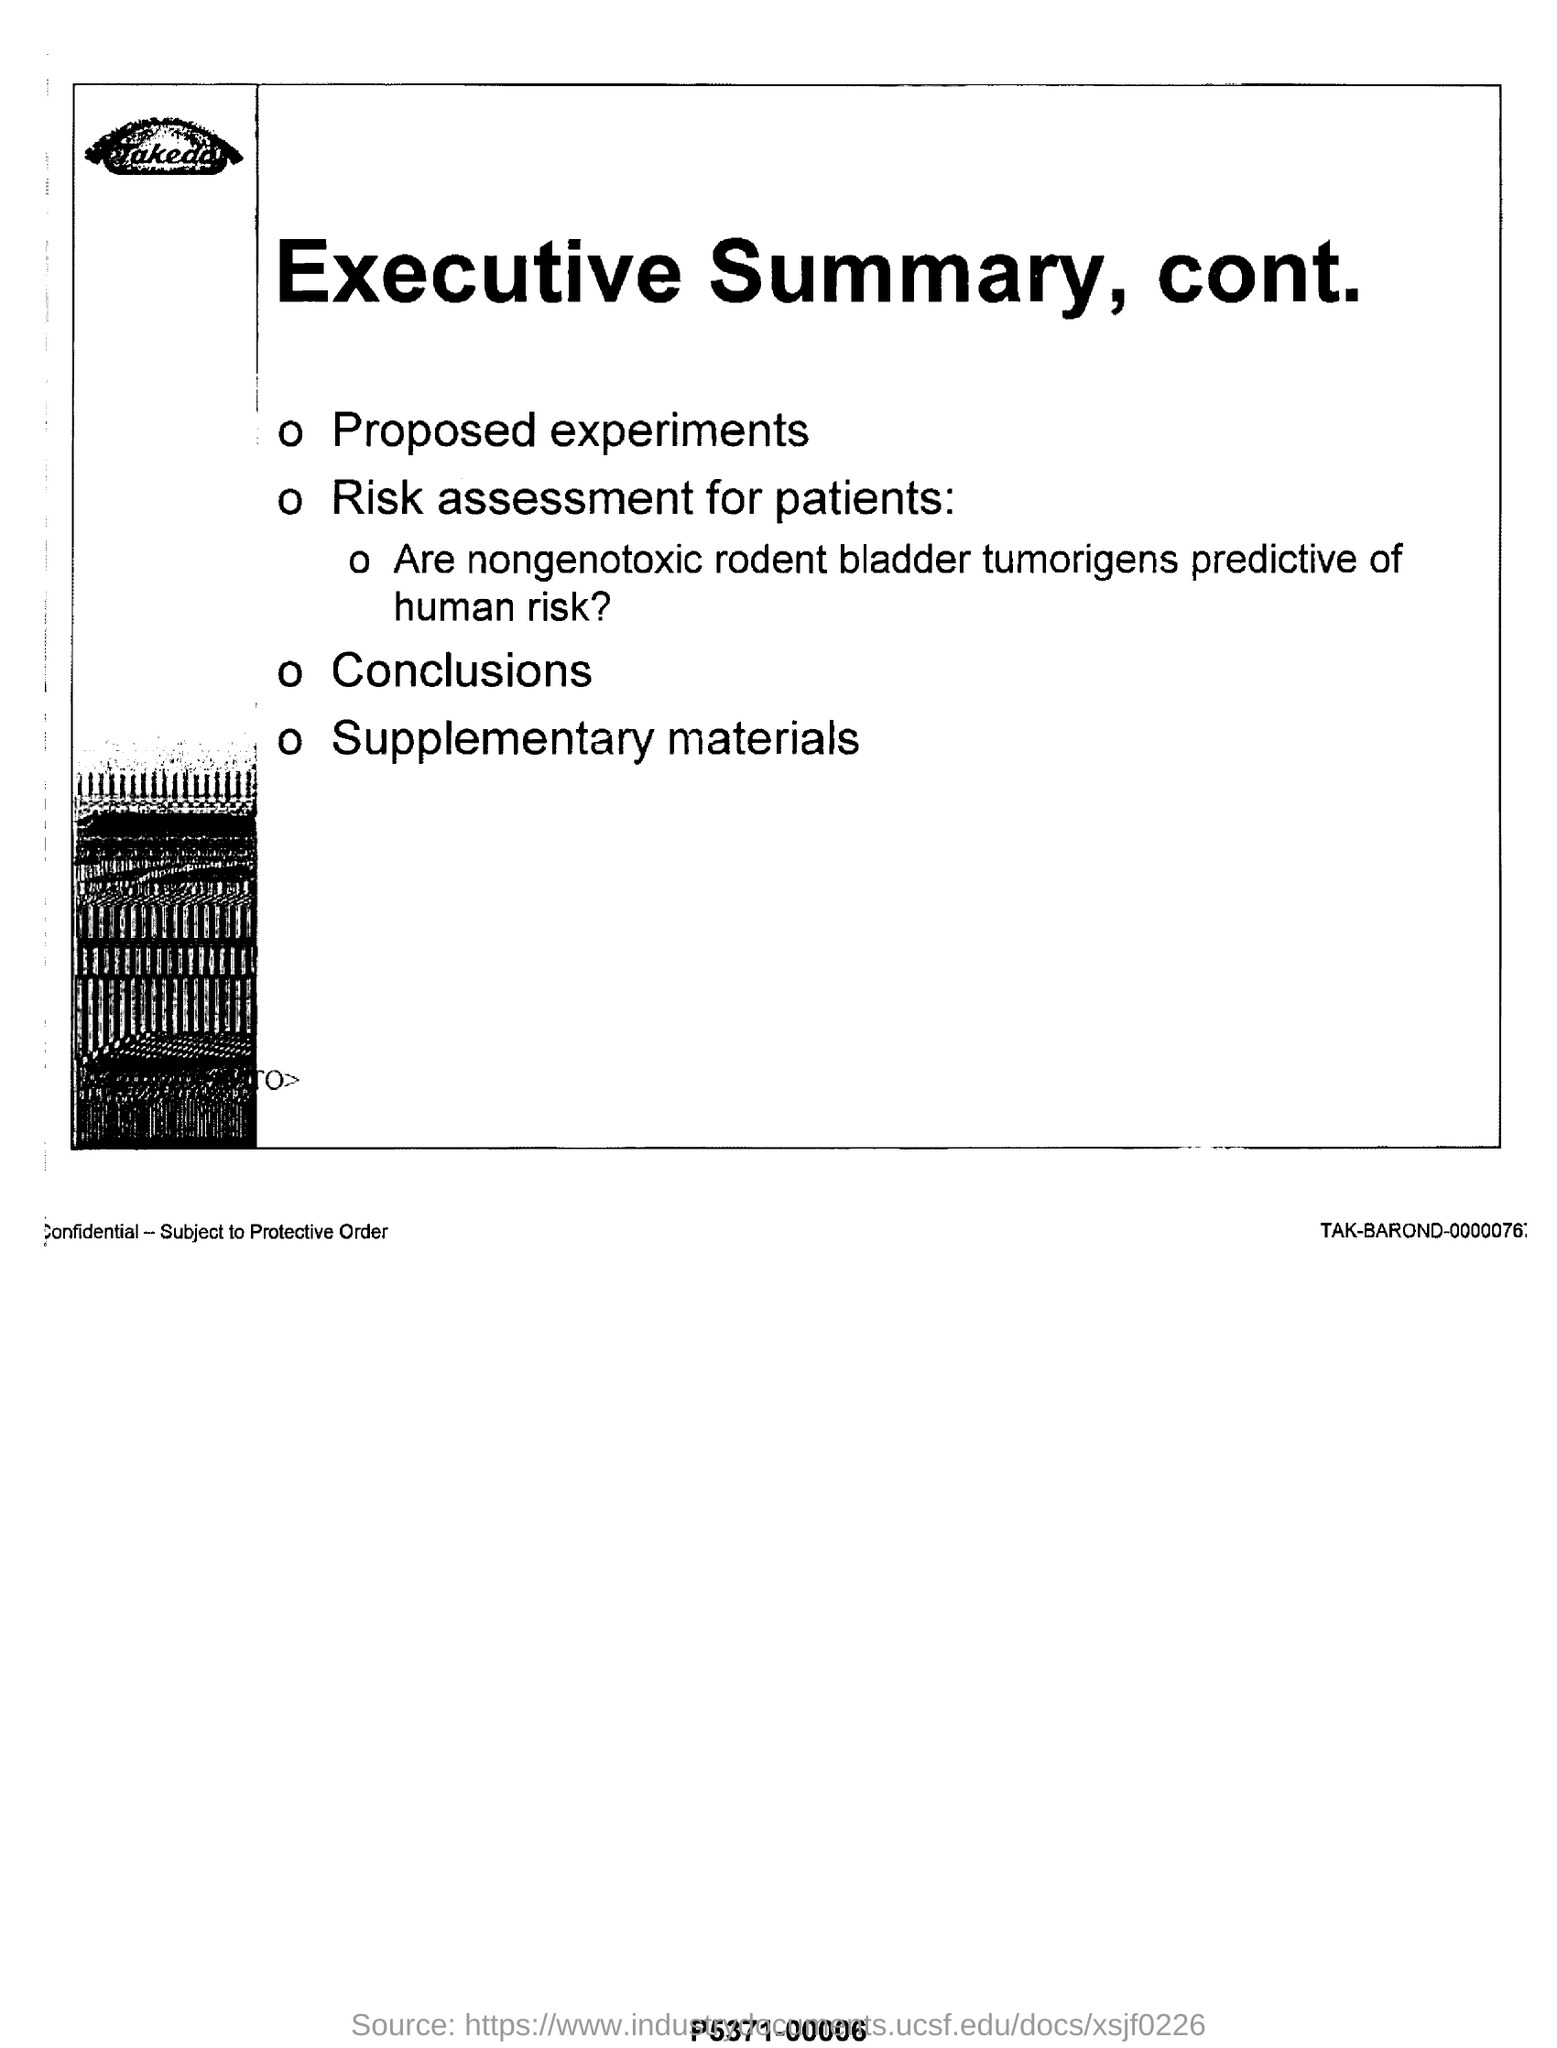Highlight a few significant elements in this photo. The executive summary, continued, includes the first proposed experiment, which aims to investigate the effects of different types of music on productivity in the workplace. The title of this page is "Executive Summary, Contents, and Objectives of the Workshop on Machine Learning (ML) for Medical Imaging Analysis 